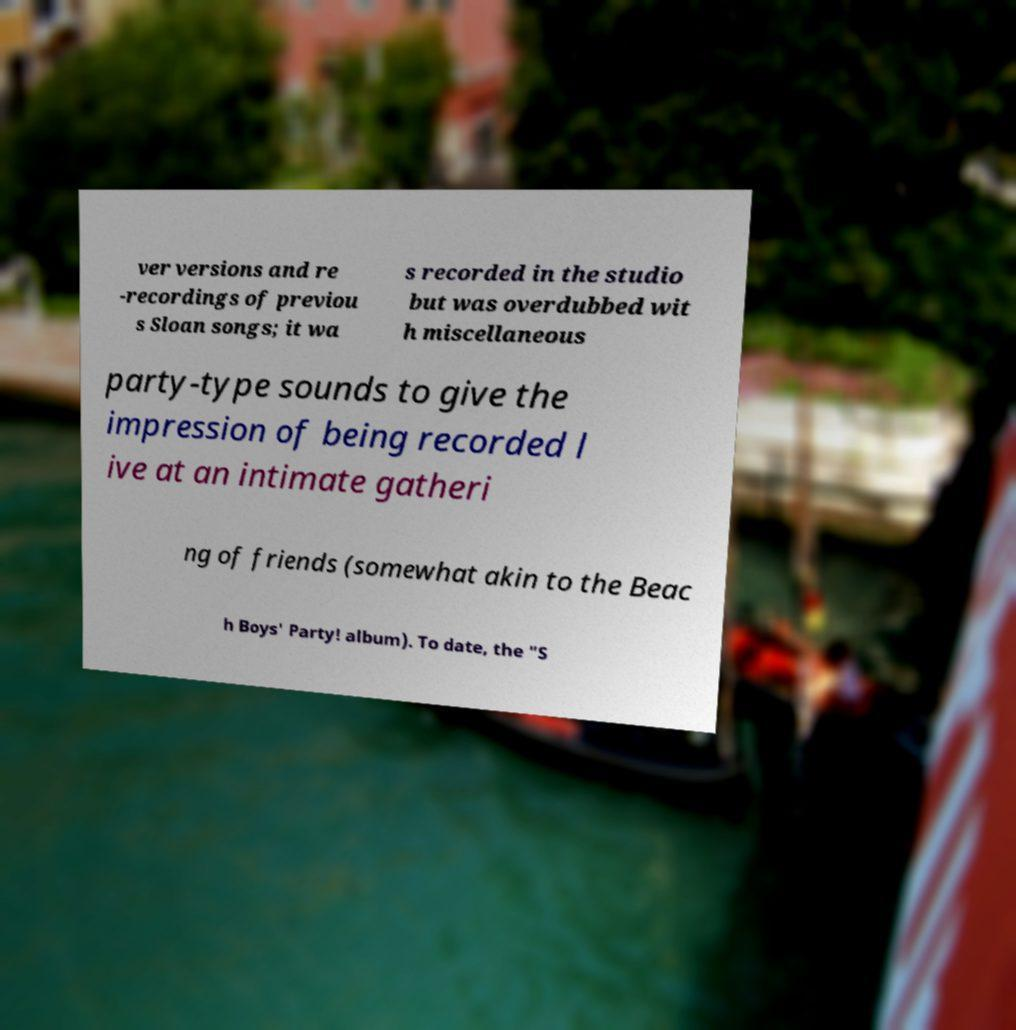What messages or text are displayed in this image? I need them in a readable, typed format. ver versions and re -recordings of previou s Sloan songs; it wa s recorded in the studio but was overdubbed wit h miscellaneous party-type sounds to give the impression of being recorded l ive at an intimate gatheri ng of friends (somewhat akin to the Beac h Boys' Party! album). To date, the "S 